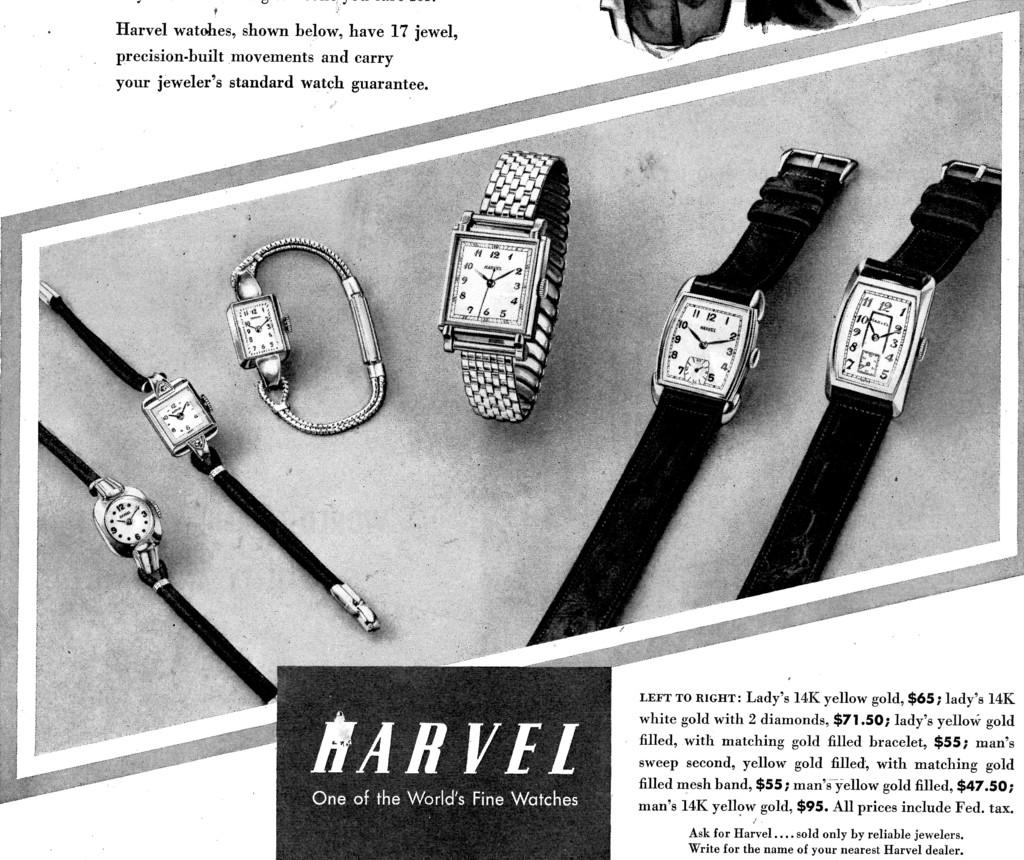<image>
Share a concise interpretation of the image provided. Six Marvel watches of different shapes and sizes are laid out in this advertisement. 